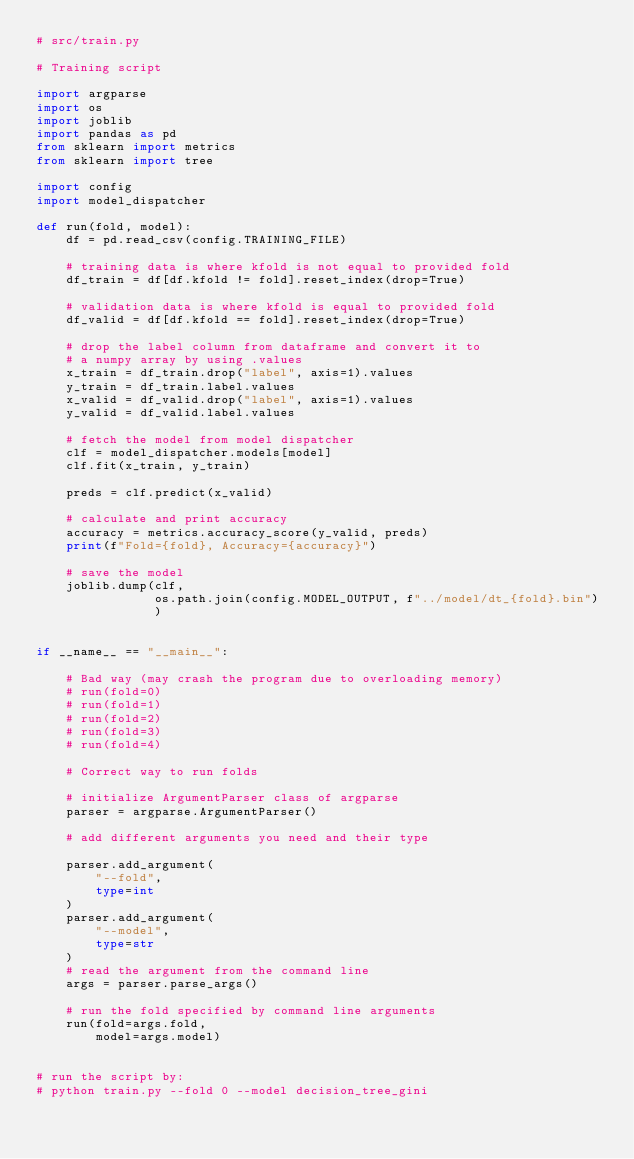Convert code to text. <code><loc_0><loc_0><loc_500><loc_500><_Python_># src/train.py

# Training script

import argparse
import os
import joblib
import pandas as pd
from sklearn import metrics
from sklearn import tree

import config
import model_dispatcher

def run(fold, model):
    df = pd.read_csv(config.TRAINING_FILE)

    # training data is where kfold is not equal to provided fold
    df_train = df[df.kfold != fold].reset_index(drop=True)

    # validation data is where kfold is equal to provided fold
    df_valid = df[df.kfold == fold].reset_index(drop=True)

    # drop the label column from dataframe and convert it to
    # a numpy array by using .values
    x_train = df_train.drop("label", axis=1).values
    y_train = df_train.label.values
    x_valid = df_valid.drop("label", axis=1).values
    y_valid = df_valid.label.values

    # fetch the model from model dispatcher
    clf = model_dispatcher.models[model]
    clf.fit(x_train, y_train)

    preds = clf.predict(x_valid)

    # calculate and print accuracy
    accuracy = metrics.accuracy_score(y_valid, preds)
    print(f"Fold={fold}, Accuracy={accuracy}")

    # save the model
    joblib.dump(clf,
                os.path.join(config.MODEL_OUTPUT, f"../model/dt_{fold}.bin")
                )


if __name__ == "__main__":

    # Bad way (may crash the program due to overloading memory)
    # run(fold=0)
    # run(fold=1)
    # run(fold=2)
    # run(fold=3)
    # run(fold=4)

    # Correct way to run folds

    # initialize ArgumentParser class of argparse
    parser = argparse.ArgumentParser()

    # add different arguments you need and their type
  
    parser.add_argument(
        "--fold",
        type=int
    )
    parser.add_argument(
        "--model",
        type=str
    )
    # read the argument from the command line
    args = parser.parse_args()

    # run the fold specified by command line arguments
    run(fold=args.fold,
        model=args.model)


# run the script by:
# python train.py --fold 0 --model decision_tree_gini</code> 